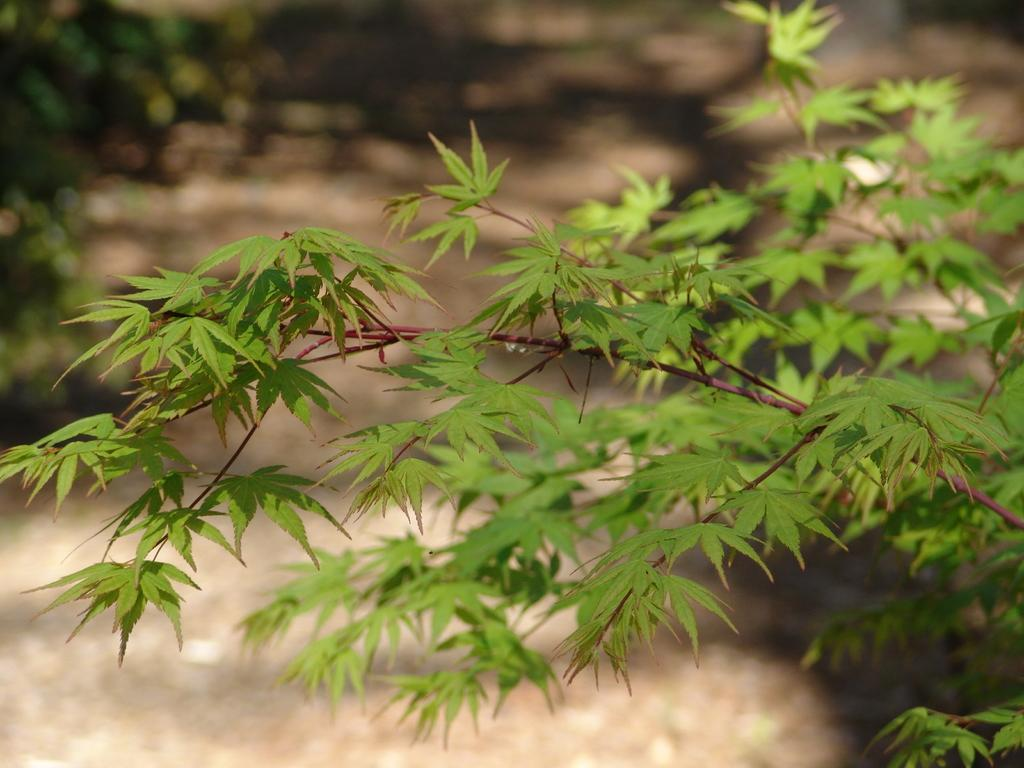What type of vegetation can be seen in the image? There are trees in the image. How would you describe the background of the image? The background of the image is blurred. What type of plant is responsible for collecting taxes in the image? There is no plant or mention of taxes in the image. 